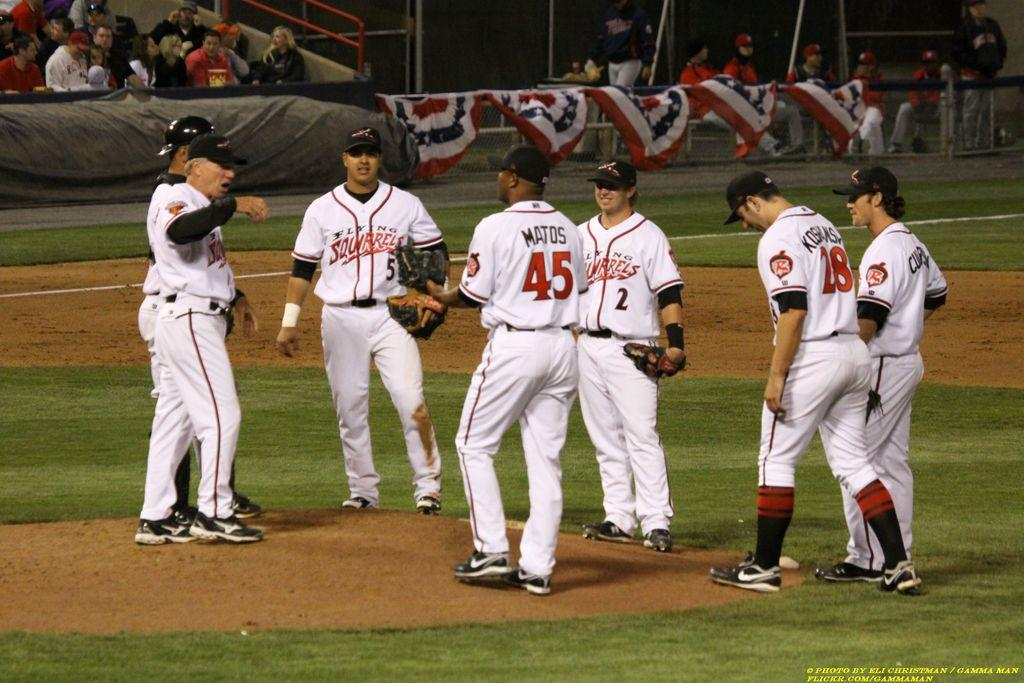<image>
Relay a brief, clear account of the picture shown. Group of baseball players including number 45 standing in a huddle. 